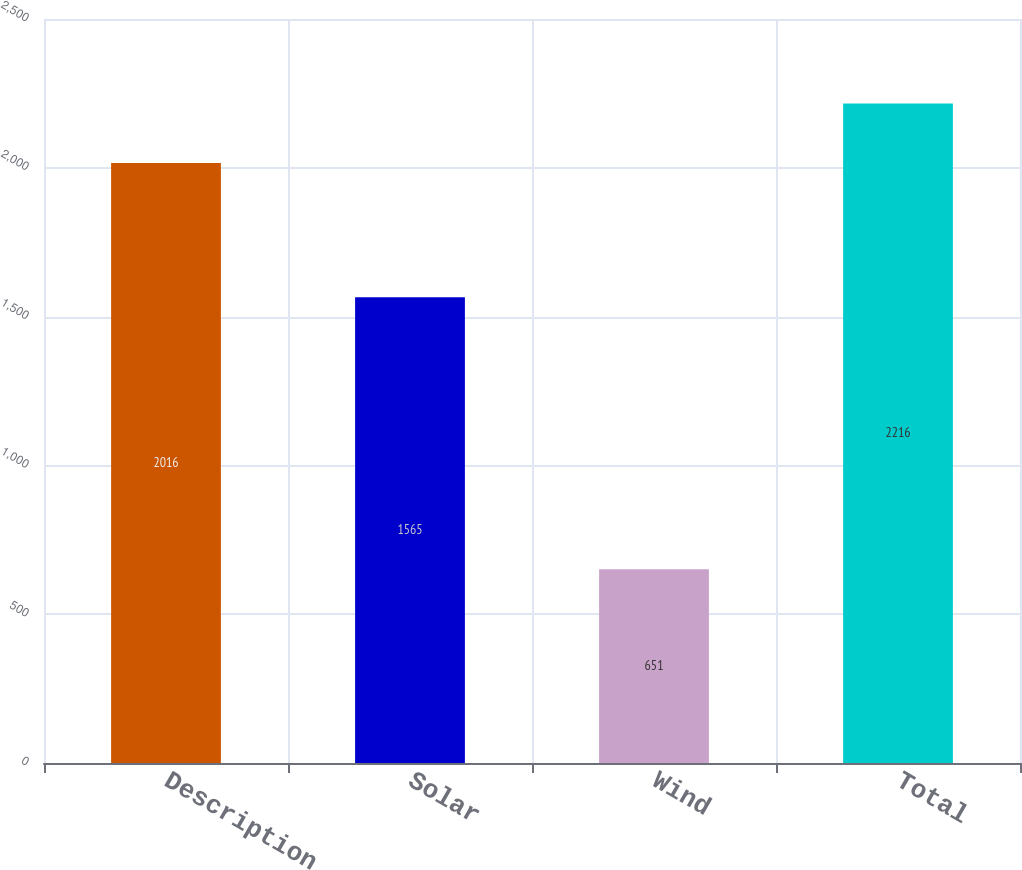Convert chart to OTSL. <chart><loc_0><loc_0><loc_500><loc_500><bar_chart><fcel>Description<fcel>Solar<fcel>Wind<fcel>Total<nl><fcel>2016<fcel>1565<fcel>651<fcel>2216<nl></chart> 